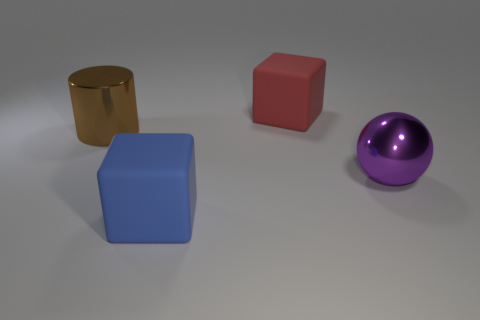Add 1 tiny brown rubber balls. How many objects exist? 5 Subtract all cylinders. How many objects are left? 3 Subtract all big red cubes. Subtract all large metallic objects. How many objects are left? 1 Add 1 big purple metallic spheres. How many big purple metallic spheres are left? 2 Add 1 big red rubber cubes. How many big red rubber cubes exist? 2 Subtract 0 purple cylinders. How many objects are left? 4 